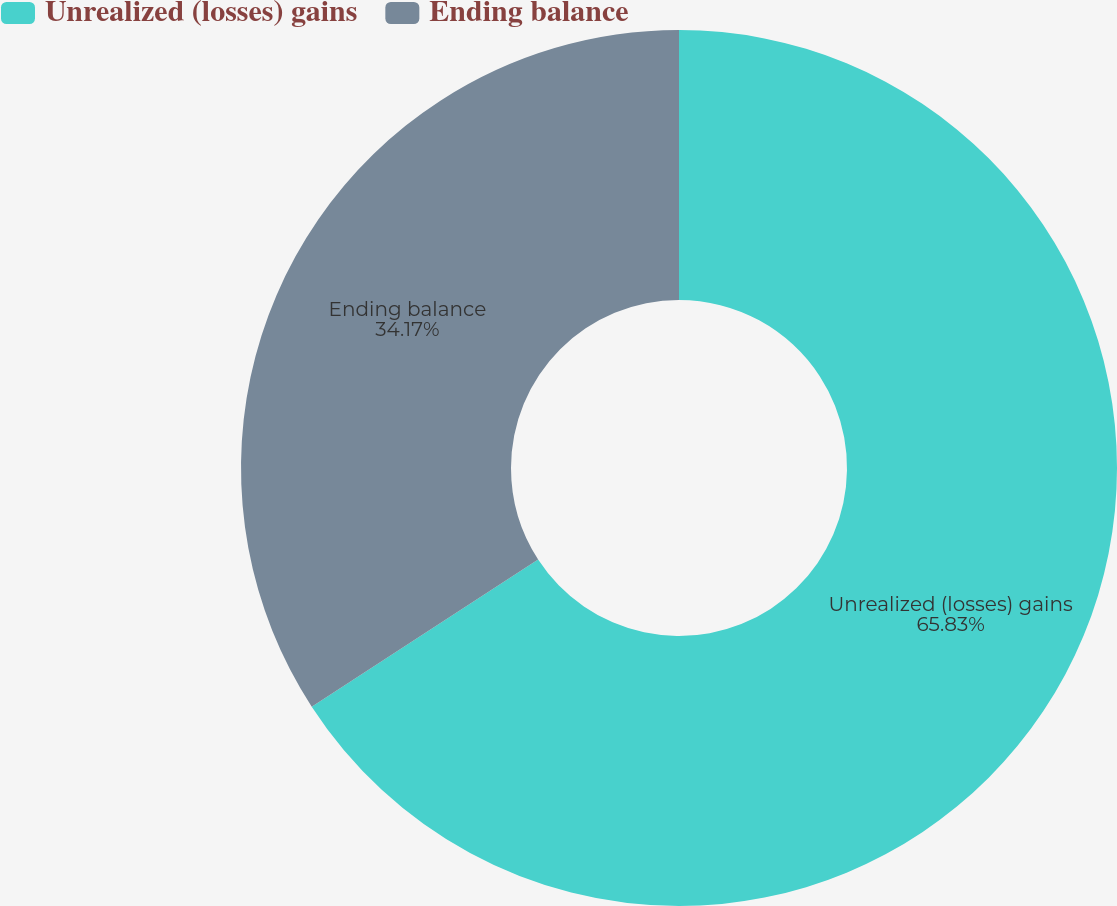Convert chart to OTSL. <chart><loc_0><loc_0><loc_500><loc_500><pie_chart><fcel>Unrealized (losses) gains<fcel>Ending balance<nl><fcel>65.83%<fcel>34.17%<nl></chart> 